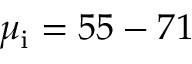Convert formula to latex. <formula><loc_0><loc_0><loc_500><loc_500>\mu _ { i } = 5 5 - 7 1</formula> 